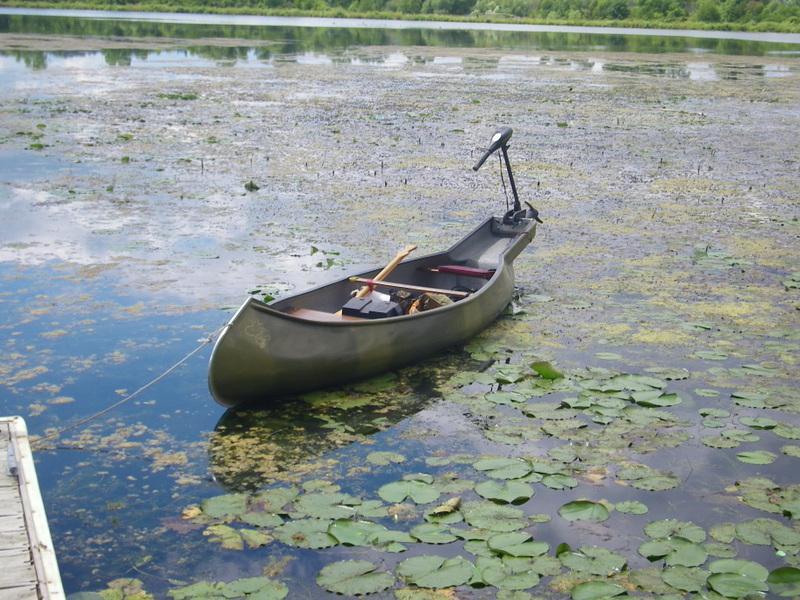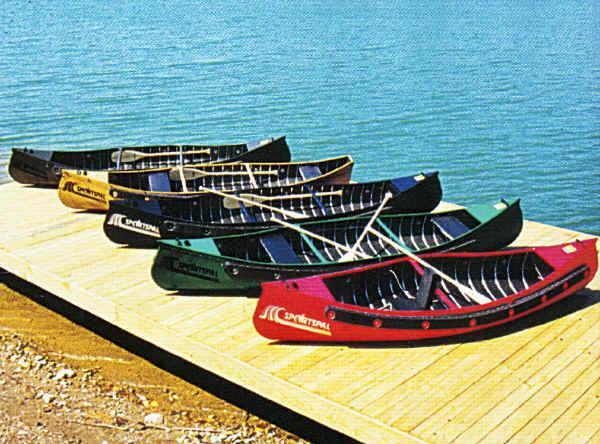The first image is the image on the left, the second image is the image on the right. Examine the images to the left and right. Is the description "rows of yellow canoes line the beach" accurate? Answer yes or no. No. The first image is the image on the left, the second image is the image on the right. Analyze the images presented: Is the assertion "At least three yellow kayaks are arranged in a row in one of the images." valid? Answer yes or no. No. 